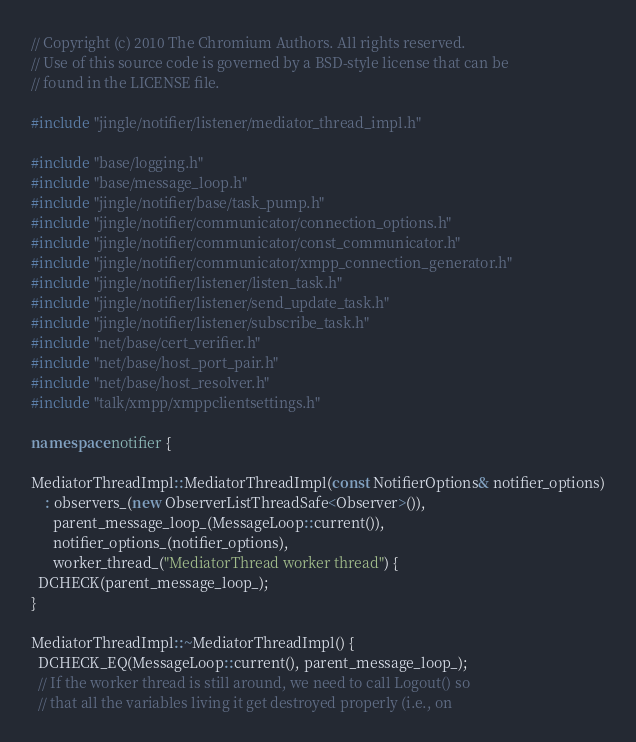Convert code to text. <code><loc_0><loc_0><loc_500><loc_500><_C++_>// Copyright (c) 2010 The Chromium Authors. All rights reserved.
// Use of this source code is governed by a BSD-style license that can be
// found in the LICENSE file.

#include "jingle/notifier/listener/mediator_thread_impl.h"

#include "base/logging.h"
#include "base/message_loop.h"
#include "jingle/notifier/base/task_pump.h"
#include "jingle/notifier/communicator/connection_options.h"
#include "jingle/notifier/communicator/const_communicator.h"
#include "jingle/notifier/communicator/xmpp_connection_generator.h"
#include "jingle/notifier/listener/listen_task.h"
#include "jingle/notifier/listener/send_update_task.h"
#include "jingle/notifier/listener/subscribe_task.h"
#include "net/base/cert_verifier.h"
#include "net/base/host_port_pair.h"
#include "net/base/host_resolver.h"
#include "talk/xmpp/xmppclientsettings.h"

namespace notifier {

MediatorThreadImpl::MediatorThreadImpl(const NotifierOptions& notifier_options)
    : observers_(new ObserverListThreadSafe<Observer>()),
      parent_message_loop_(MessageLoop::current()),
      notifier_options_(notifier_options),
      worker_thread_("MediatorThread worker thread") {
  DCHECK(parent_message_loop_);
}

MediatorThreadImpl::~MediatorThreadImpl() {
  DCHECK_EQ(MessageLoop::current(), parent_message_loop_);
  // If the worker thread is still around, we need to call Logout() so
  // that all the variables living it get destroyed properly (i.e., on</code> 